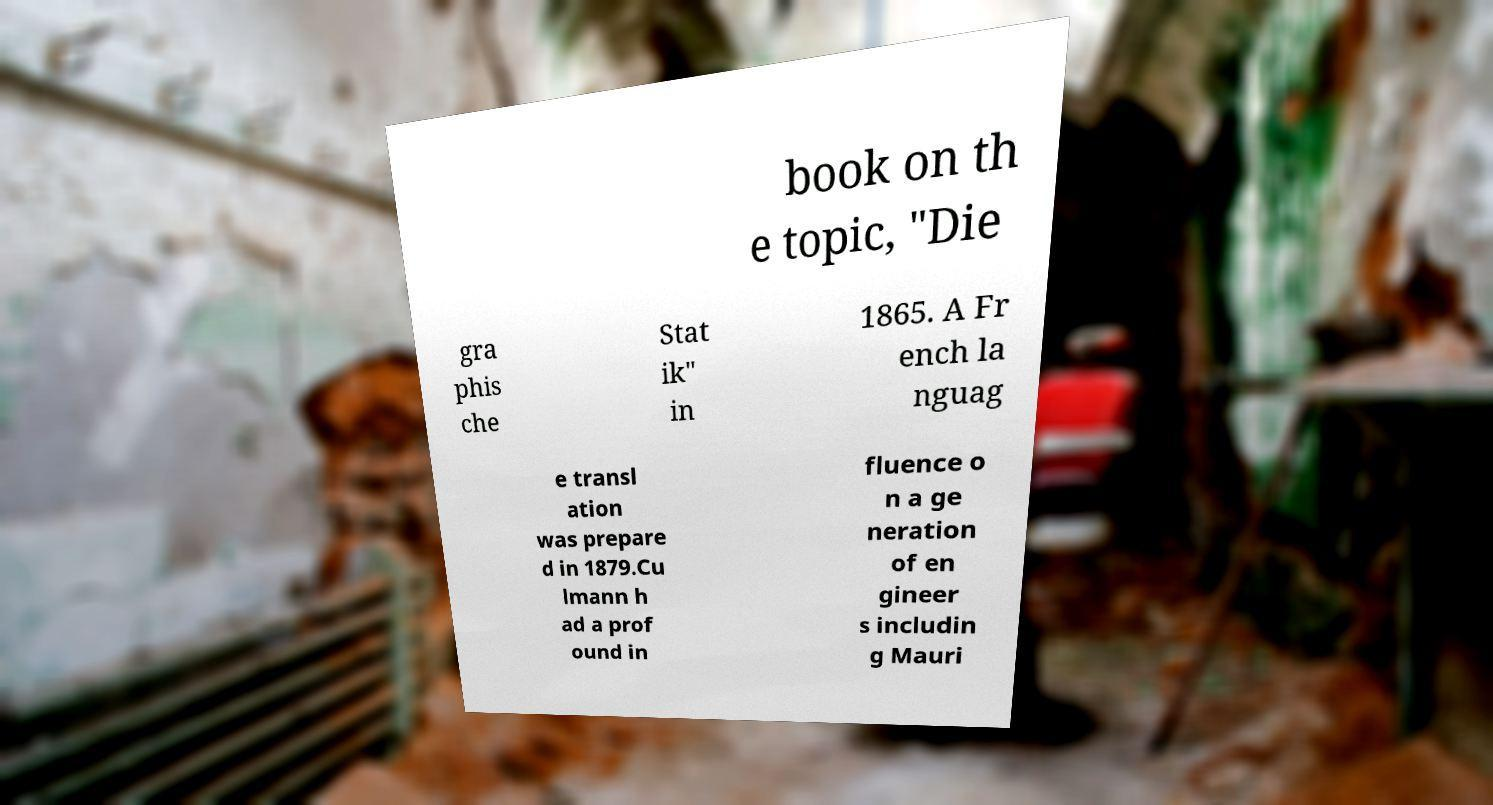Could you extract and type out the text from this image? book on th e topic, "Die gra phis che Stat ik" in 1865. A Fr ench la nguag e transl ation was prepare d in 1879.Cu lmann h ad a prof ound in fluence o n a ge neration of en gineer s includin g Mauri 